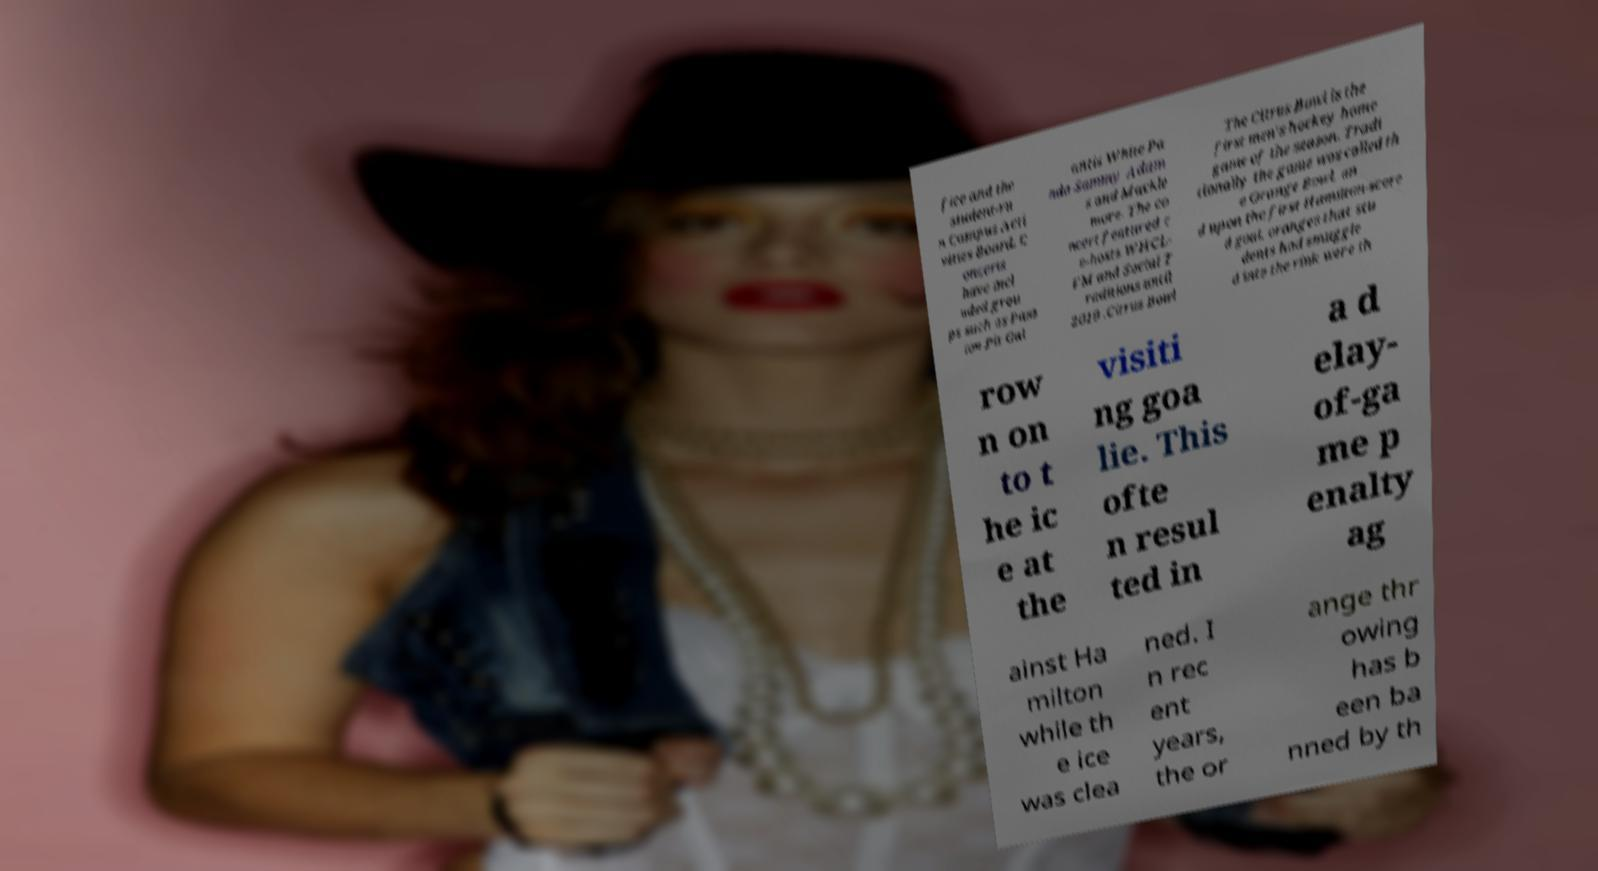I need the written content from this picture converted into text. Can you do that? fice and the student-ru n Campus Acti vities Board. C oncerts have incl uded grou ps such as Pass ion Pit Gal antis White Pa nda Sammy Adam s and Mackle more. The co ncert featured c o-hosts WHCL- FM and Social T raditions until 2019 .Citrus Bowl The Citrus Bowl is the first men's hockey home game of the season. Tradi tionally the game was called th e Orange Bowl, an d upon the first Hamilton-score d goal, oranges that stu dents had smuggle d into the rink were th row n on to t he ic e at the visiti ng goa lie. This ofte n resul ted in a d elay- of-ga me p enalty ag ainst Ha milton while th e ice was clea ned. I n rec ent years, the or ange thr owing has b een ba nned by th 